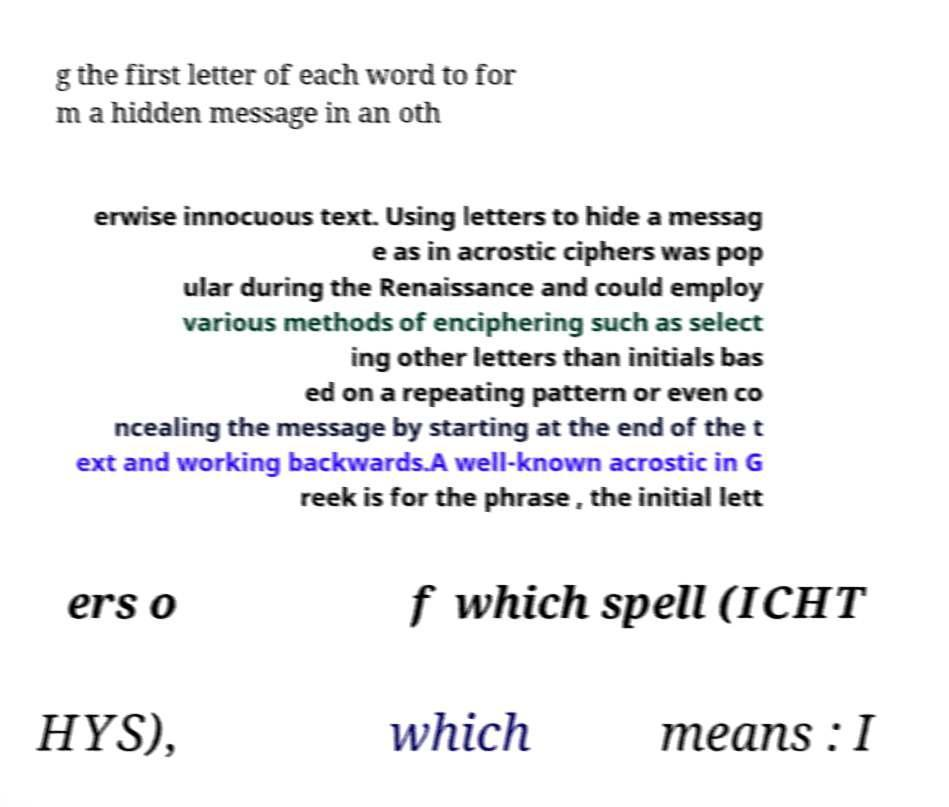Can you read and provide the text displayed in the image?This photo seems to have some interesting text. Can you extract and type it out for me? g the first letter of each word to for m a hidden message in an oth erwise innocuous text. Using letters to hide a messag e as in acrostic ciphers was pop ular during the Renaissance and could employ various methods of enciphering such as select ing other letters than initials bas ed on a repeating pattern or even co ncealing the message by starting at the end of the t ext and working backwards.A well-known acrostic in G reek is for the phrase , the initial lett ers o f which spell (ICHT HYS), which means : I 